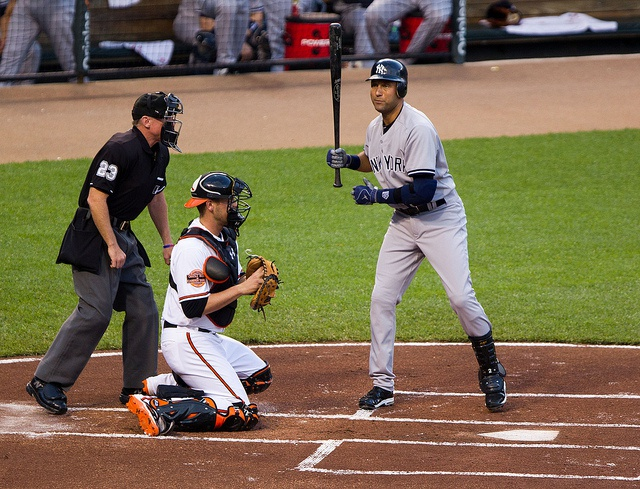Describe the objects in this image and their specific colors. I can see people in gray, black, and olive tones, people in gray, darkgray, black, lavender, and lightgray tones, people in gray, lavender, black, and maroon tones, people in gray and black tones, and people in gray, darkgray, and black tones in this image. 